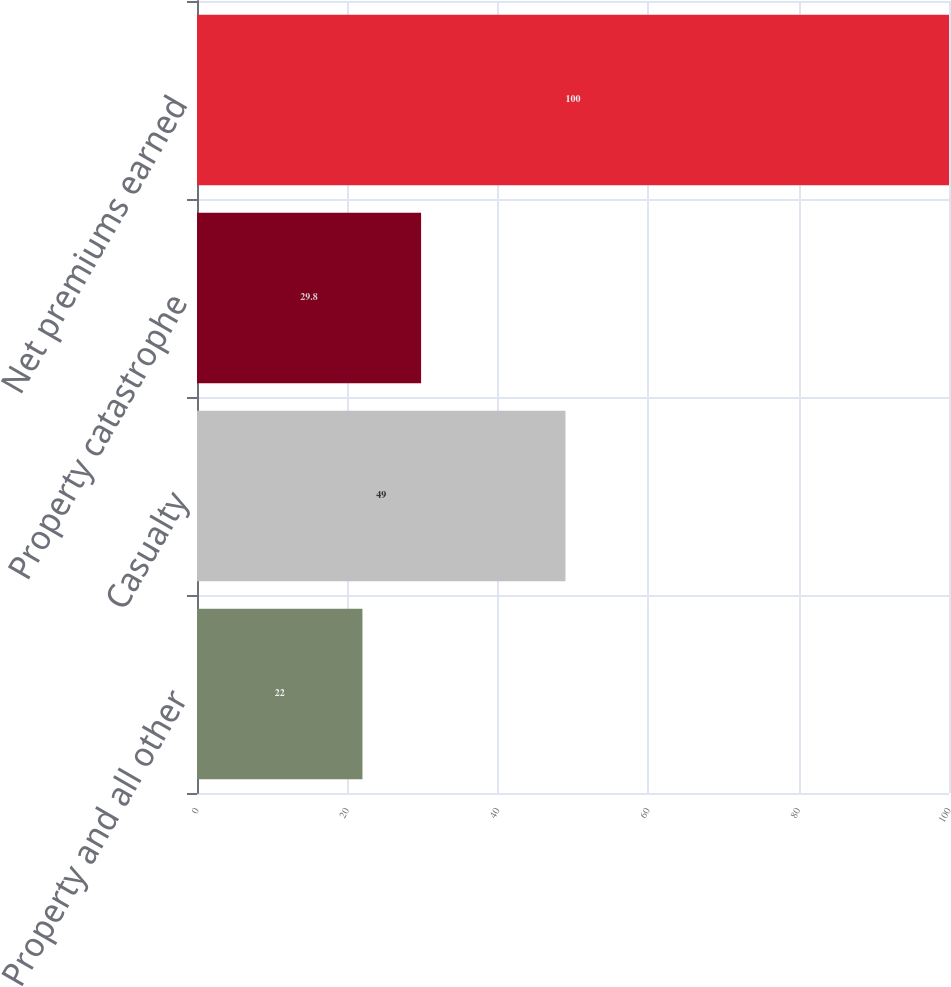<chart> <loc_0><loc_0><loc_500><loc_500><bar_chart><fcel>Property and all other<fcel>Casualty<fcel>Property catastrophe<fcel>Net premiums earned<nl><fcel>22<fcel>49<fcel>29.8<fcel>100<nl></chart> 